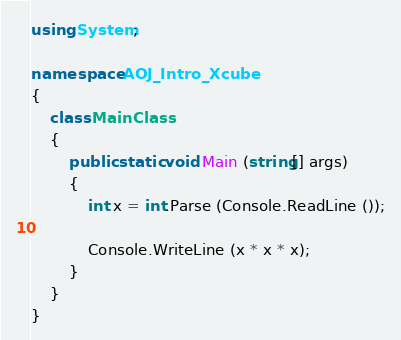Convert code to text. <code><loc_0><loc_0><loc_500><loc_500><_C#_>using System;

namespace AOJ_Intro_Xcube
{
	class MainClass
	{
		public static void Main (string[] args)
		{
			int x = int.Parse (Console.ReadLine ());

			Console.WriteLine (x * x * x);
		}
	}
}</code> 